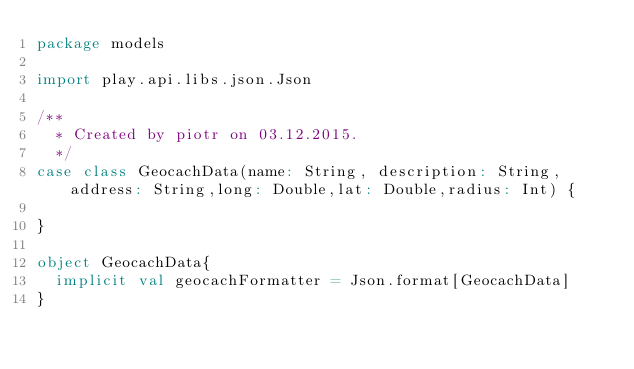<code> <loc_0><loc_0><loc_500><loc_500><_Scala_>package models

import play.api.libs.json.Json

/**
  * Created by piotr on 03.12.2015.
  */
case class GeocachData(name: String, description: String,address: String,long: Double,lat: Double,radius: Int) {

}

object GeocachData{
  implicit val geocachFormatter = Json.format[GeocachData]
}</code> 